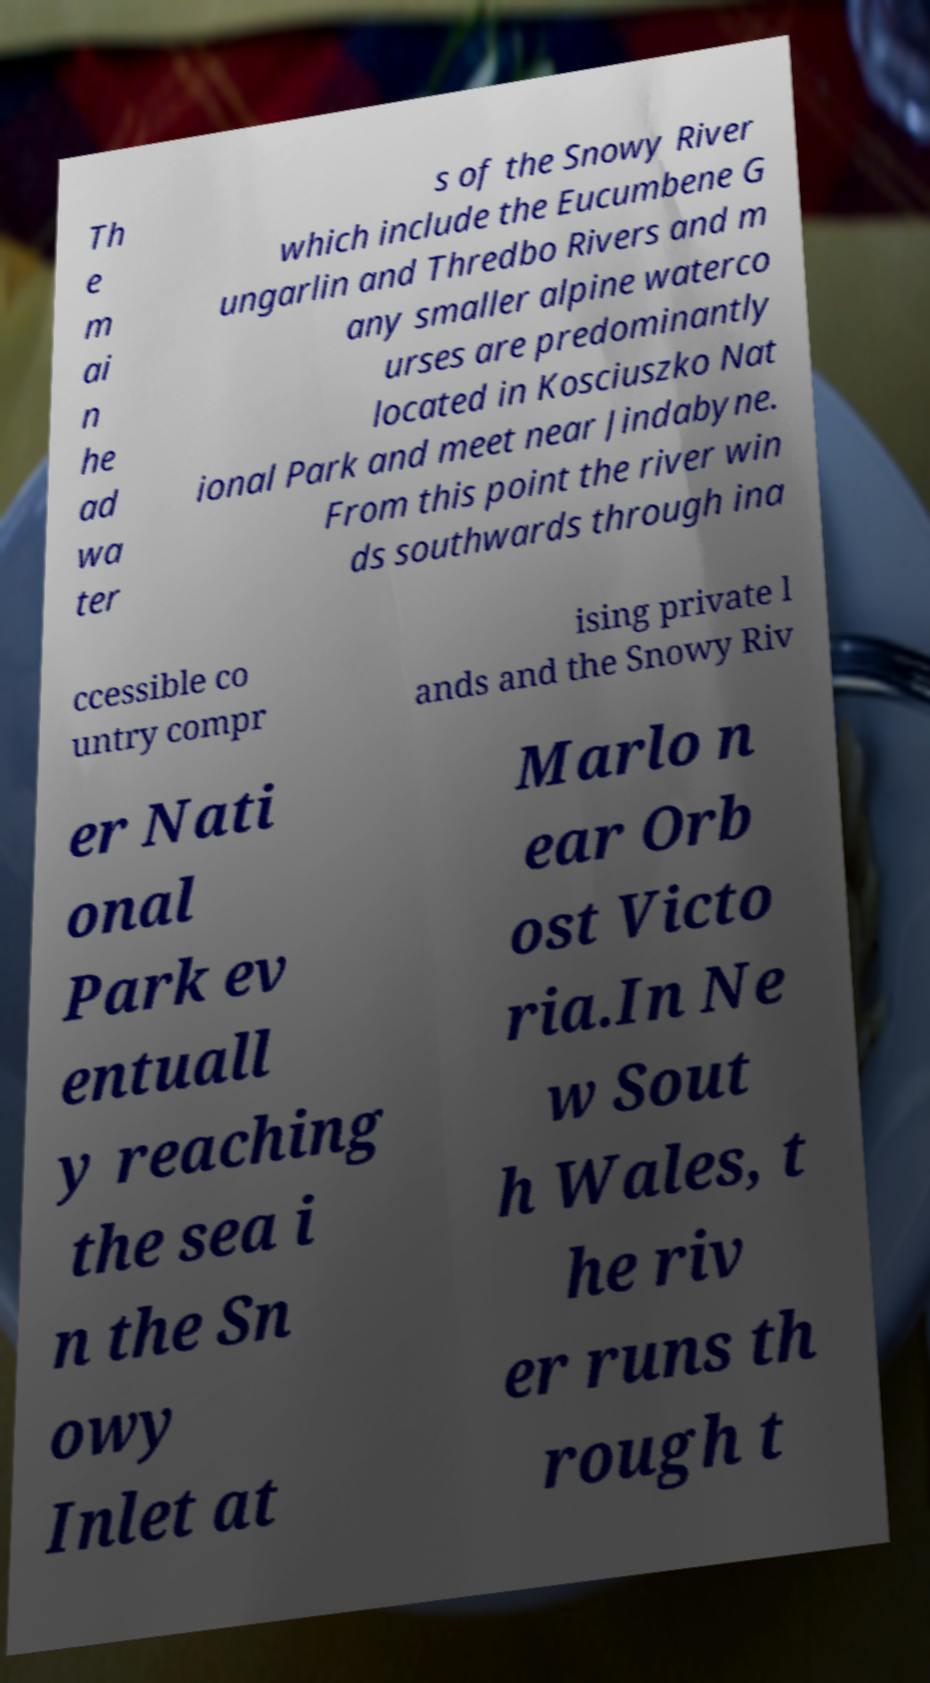There's text embedded in this image that I need extracted. Can you transcribe it verbatim? Th e m ai n he ad wa ter s of the Snowy River which include the Eucumbene G ungarlin and Thredbo Rivers and m any smaller alpine waterco urses are predominantly located in Kosciuszko Nat ional Park and meet near Jindabyne. From this point the river win ds southwards through ina ccessible co untry compr ising private l ands and the Snowy Riv er Nati onal Park ev entuall y reaching the sea i n the Sn owy Inlet at Marlo n ear Orb ost Victo ria.In Ne w Sout h Wales, t he riv er runs th rough t 